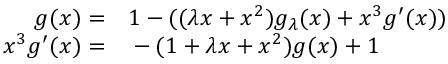<formula> <loc_0><loc_0><loc_500><loc_500>\begin{array} { r l } { g ( x ) = } & 1 - ( ( \lambda x + x ^ { 2 } ) g _ { \lambda } ( x ) + x ^ { 3 } g ^ { \prime } ( x ) ) } \\ { x ^ { 3 } g ^ { \prime } ( x ) = } & - ( 1 + \lambda x + x ^ { 2 } ) g ( x ) + 1 } \end{array}</formula> 